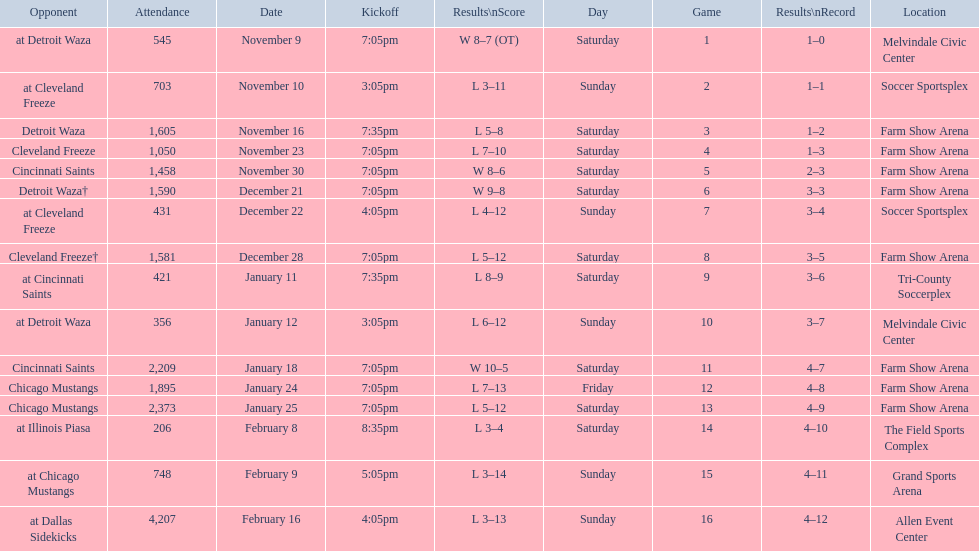How many games did the harrisburg heat win in which they scored eight or more goals? 4. 